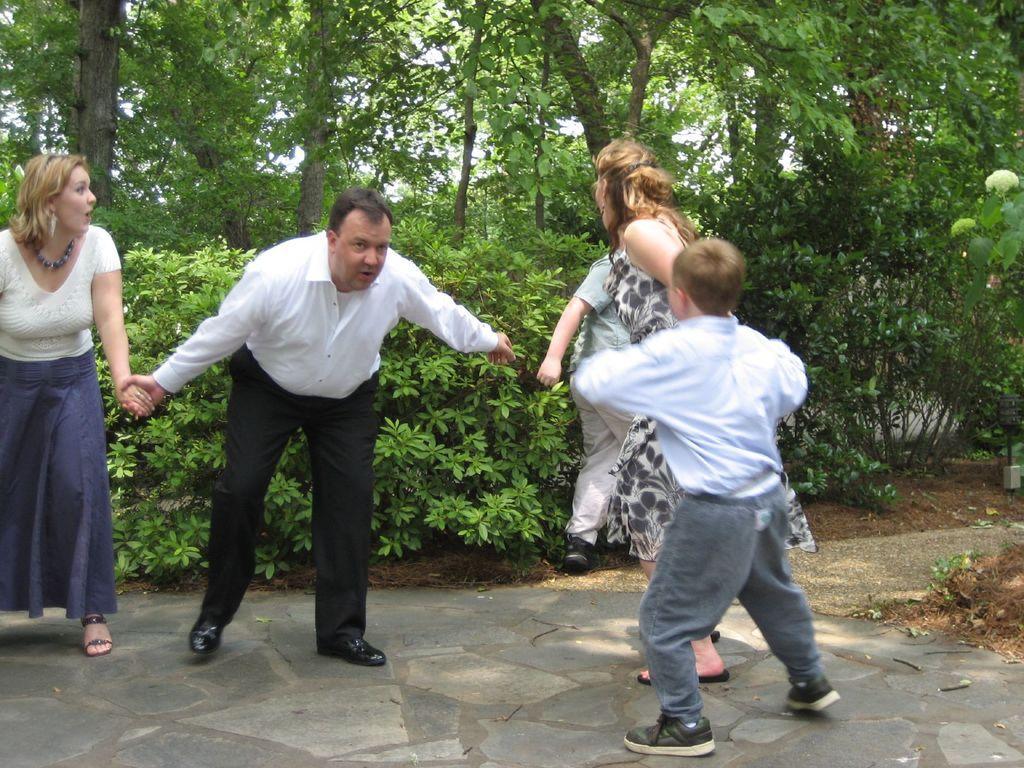Please provide a concise description of this image. In this image I can see group of people playing game. The person standing in front wearing white shirt, black pant and the person at left wearing white shirt, purple skirt. At back I can see trees in green color, sky in white color. 